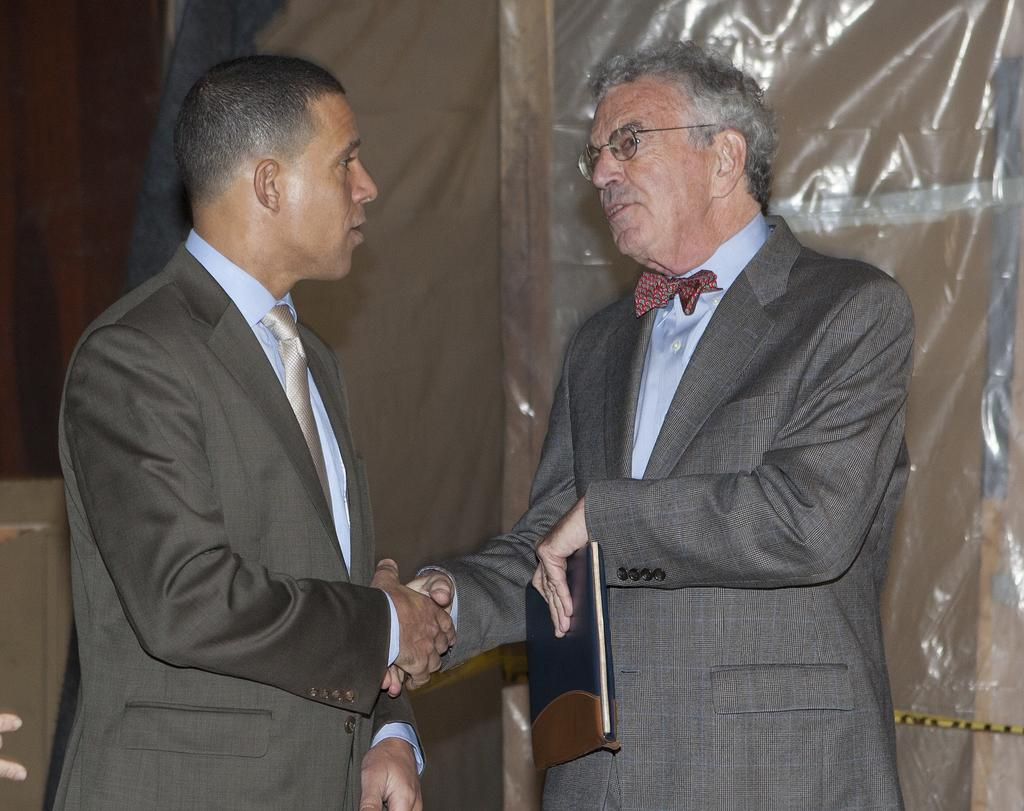How many people are in the image? There are two men in the image. What are the men doing in the image? The men are standing and shaking hands. What are the men wearing in the image? Both men are wearing suits. Can you describe the appearance of the man on the right side? The man on the right side is wearing spectacles. What is the man on the right side holding in his hand? The man on the right side is holding something in his hand, but we cannot determine what it is from the image. What type of guitar is the man on the left side playing in the image? There is no guitar present in the image; the men are shaking hands and not playing any musical instruments. 